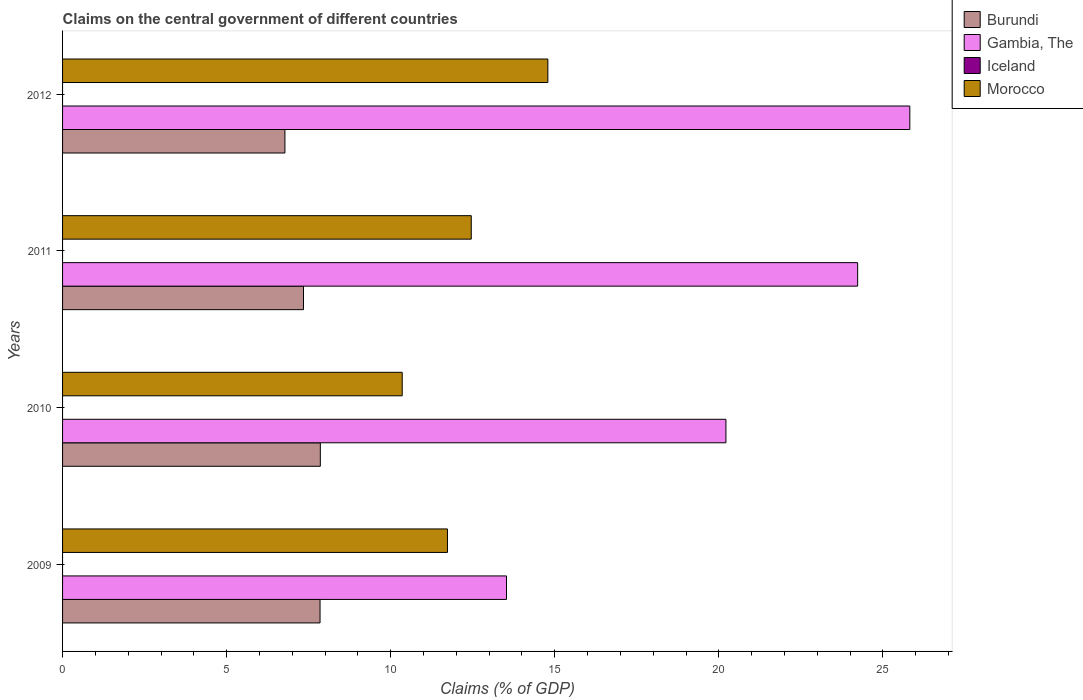How many groups of bars are there?
Provide a short and direct response. 4. Are the number of bars per tick equal to the number of legend labels?
Offer a terse response. No. Are the number of bars on each tick of the Y-axis equal?
Your response must be concise. Yes. How many bars are there on the 3rd tick from the bottom?
Your answer should be very brief. 3. What is the label of the 2nd group of bars from the top?
Offer a very short reply. 2011. In how many cases, is the number of bars for a given year not equal to the number of legend labels?
Make the answer very short. 4. What is the percentage of GDP claimed on the central government in Gambia, The in 2010?
Ensure brevity in your answer.  20.22. Across all years, what is the maximum percentage of GDP claimed on the central government in Morocco?
Your response must be concise. 14.79. Across all years, what is the minimum percentage of GDP claimed on the central government in Morocco?
Ensure brevity in your answer.  10.35. What is the total percentage of GDP claimed on the central government in Gambia, The in the graph?
Your answer should be compact. 83.8. What is the difference between the percentage of GDP claimed on the central government in Burundi in 2009 and that in 2011?
Your answer should be compact. 0.5. What is the difference between the percentage of GDP claimed on the central government in Iceland in 2010 and the percentage of GDP claimed on the central government in Morocco in 2011?
Make the answer very short. -12.46. What is the average percentage of GDP claimed on the central government in Gambia, The per year?
Provide a succinct answer. 20.95. In the year 2010, what is the difference between the percentage of GDP claimed on the central government in Burundi and percentage of GDP claimed on the central government in Gambia, The?
Provide a short and direct response. -12.36. What is the ratio of the percentage of GDP claimed on the central government in Burundi in 2009 to that in 2011?
Ensure brevity in your answer.  1.07. What is the difference between the highest and the second highest percentage of GDP claimed on the central government in Burundi?
Give a very brief answer. 0.01. What is the difference between the highest and the lowest percentage of GDP claimed on the central government in Gambia, The?
Provide a succinct answer. 12.29. In how many years, is the percentage of GDP claimed on the central government in Burundi greater than the average percentage of GDP claimed on the central government in Burundi taken over all years?
Your answer should be very brief. 2. Is the sum of the percentage of GDP claimed on the central government in Morocco in 2009 and 2012 greater than the maximum percentage of GDP claimed on the central government in Gambia, The across all years?
Your response must be concise. Yes. Is it the case that in every year, the sum of the percentage of GDP claimed on the central government in Burundi and percentage of GDP claimed on the central government in Iceland is greater than the sum of percentage of GDP claimed on the central government in Morocco and percentage of GDP claimed on the central government in Gambia, The?
Your response must be concise. No. How many bars are there?
Ensure brevity in your answer.  12. Does the graph contain any zero values?
Give a very brief answer. Yes. Where does the legend appear in the graph?
Your response must be concise. Top right. How many legend labels are there?
Give a very brief answer. 4. What is the title of the graph?
Your response must be concise. Claims on the central government of different countries. Does "Myanmar" appear as one of the legend labels in the graph?
Offer a very short reply. No. What is the label or title of the X-axis?
Your answer should be compact. Claims (% of GDP). What is the label or title of the Y-axis?
Offer a very short reply. Years. What is the Claims (% of GDP) of Burundi in 2009?
Give a very brief answer. 7.85. What is the Claims (% of GDP) in Gambia, The in 2009?
Offer a terse response. 13.53. What is the Claims (% of GDP) of Iceland in 2009?
Give a very brief answer. 0. What is the Claims (% of GDP) of Morocco in 2009?
Provide a succinct answer. 11.73. What is the Claims (% of GDP) of Burundi in 2010?
Give a very brief answer. 7.86. What is the Claims (% of GDP) in Gambia, The in 2010?
Offer a very short reply. 20.22. What is the Claims (% of GDP) of Morocco in 2010?
Keep it short and to the point. 10.35. What is the Claims (% of GDP) in Burundi in 2011?
Ensure brevity in your answer.  7.34. What is the Claims (% of GDP) in Gambia, The in 2011?
Provide a succinct answer. 24.23. What is the Claims (% of GDP) in Morocco in 2011?
Offer a very short reply. 12.46. What is the Claims (% of GDP) in Burundi in 2012?
Your response must be concise. 6.78. What is the Claims (% of GDP) in Gambia, The in 2012?
Offer a very short reply. 25.82. What is the Claims (% of GDP) of Morocco in 2012?
Ensure brevity in your answer.  14.79. Across all years, what is the maximum Claims (% of GDP) of Burundi?
Offer a very short reply. 7.86. Across all years, what is the maximum Claims (% of GDP) of Gambia, The?
Offer a terse response. 25.82. Across all years, what is the maximum Claims (% of GDP) of Morocco?
Ensure brevity in your answer.  14.79. Across all years, what is the minimum Claims (% of GDP) of Burundi?
Offer a terse response. 6.78. Across all years, what is the minimum Claims (% of GDP) of Gambia, The?
Your response must be concise. 13.53. Across all years, what is the minimum Claims (% of GDP) of Morocco?
Offer a terse response. 10.35. What is the total Claims (% of GDP) in Burundi in the graph?
Provide a succinct answer. 29.82. What is the total Claims (% of GDP) of Gambia, The in the graph?
Make the answer very short. 83.8. What is the total Claims (% of GDP) in Morocco in the graph?
Offer a very short reply. 49.33. What is the difference between the Claims (% of GDP) in Burundi in 2009 and that in 2010?
Your response must be concise. -0.01. What is the difference between the Claims (% of GDP) of Gambia, The in 2009 and that in 2010?
Your response must be concise. -6.69. What is the difference between the Claims (% of GDP) of Morocco in 2009 and that in 2010?
Offer a very short reply. 1.38. What is the difference between the Claims (% of GDP) of Burundi in 2009 and that in 2011?
Your answer should be very brief. 0.5. What is the difference between the Claims (% of GDP) of Gambia, The in 2009 and that in 2011?
Offer a terse response. -10.7. What is the difference between the Claims (% of GDP) of Morocco in 2009 and that in 2011?
Offer a terse response. -0.73. What is the difference between the Claims (% of GDP) of Burundi in 2009 and that in 2012?
Offer a very short reply. 1.07. What is the difference between the Claims (% of GDP) of Gambia, The in 2009 and that in 2012?
Keep it short and to the point. -12.29. What is the difference between the Claims (% of GDP) of Morocco in 2009 and that in 2012?
Provide a short and direct response. -3.06. What is the difference between the Claims (% of GDP) in Burundi in 2010 and that in 2011?
Your answer should be compact. 0.51. What is the difference between the Claims (% of GDP) in Gambia, The in 2010 and that in 2011?
Give a very brief answer. -4.01. What is the difference between the Claims (% of GDP) of Morocco in 2010 and that in 2011?
Provide a short and direct response. -2.1. What is the difference between the Claims (% of GDP) of Burundi in 2010 and that in 2012?
Offer a very short reply. 1.08. What is the difference between the Claims (% of GDP) of Gambia, The in 2010 and that in 2012?
Your answer should be very brief. -5.6. What is the difference between the Claims (% of GDP) in Morocco in 2010 and that in 2012?
Your answer should be compact. -4.44. What is the difference between the Claims (% of GDP) in Burundi in 2011 and that in 2012?
Your response must be concise. 0.57. What is the difference between the Claims (% of GDP) in Gambia, The in 2011 and that in 2012?
Keep it short and to the point. -1.59. What is the difference between the Claims (% of GDP) in Morocco in 2011 and that in 2012?
Your answer should be compact. -2.33. What is the difference between the Claims (% of GDP) in Burundi in 2009 and the Claims (% of GDP) in Gambia, The in 2010?
Offer a very short reply. -12.37. What is the difference between the Claims (% of GDP) of Burundi in 2009 and the Claims (% of GDP) of Morocco in 2010?
Your answer should be very brief. -2.5. What is the difference between the Claims (% of GDP) of Gambia, The in 2009 and the Claims (% of GDP) of Morocco in 2010?
Give a very brief answer. 3.18. What is the difference between the Claims (% of GDP) in Burundi in 2009 and the Claims (% of GDP) in Gambia, The in 2011?
Offer a very short reply. -16.38. What is the difference between the Claims (% of GDP) in Burundi in 2009 and the Claims (% of GDP) in Morocco in 2011?
Keep it short and to the point. -4.61. What is the difference between the Claims (% of GDP) in Gambia, The in 2009 and the Claims (% of GDP) in Morocco in 2011?
Offer a very short reply. 1.07. What is the difference between the Claims (% of GDP) of Burundi in 2009 and the Claims (% of GDP) of Gambia, The in 2012?
Make the answer very short. -17.97. What is the difference between the Claims (% of GDP) of Burundi in 2009 and the Claims (% of GDP) of Morocco in 2012?
Provide a succinct answer. -6.94. What is the difference between the Claims (% of GDP) of Gambia, The in 2009 and the Claims (% of GDP) of Morocco in 2012?
Provide a succinct answer. -1.26. What is the difference between the Claims (% of GDP) of Burundi in 2010 and the Claims (% of GDP) of Gambia, The in 2011?
Your answer should be compact. -16.38. What is the difference between the Claims (% of GDP) of Burundi in 2010 and the Claims (% of GDP) of Morocco in 2011?
Provide a short and direct response. -4.6. What is the difference between the Claims (% of GDP) in Gambia, The in 2010 and the Claims (% of GDP) in Morocco in 2011?
Keep it short and to the point. 7.76. What is the difference between the Claims (% of GDP) of Burundi in 2010 and the Claims (% of GDP) of Gambia, The in 2012?
Keep it short and to the point. -17.97. What is the difference between the Claims (% of GDP) of Burundi in 2010 and the Claims (% of GDP) of Morocco in 2012?
Make the answer very short. -6.93. What is the difference between the Claims (% of GDP) of Gambia, The in 2010 and the Claims (% of GDP) of Morocco in 2012?
Offer a terse response. 5.43. What is the difference between the Claims (% of GDP) of Burundi in 2011 and the Claims (% of GDP) of Gambia, The in 2012?
Your answer should be very brief. -18.48. What is the difference between the Claims (% of GDP) in Burundi in 2011 and the Claims (% of GDP) in Morocco in 2012?
Your response must be concise. -7.45. What is the difference between the Claims (% of GDP) of Gambia, The in 2011 and the Claims (% of GDP) of Morocco in 2012?
Give a very brief answer. 9.44. What is the average Claims (% of GDP) in Burundi per year?
Offer a very short reply. 7.46. What is the average Claims (% of GDP) in Gambia, The per year?
Offer a very short reply. 20.95. What is the average Claims (% of GDP) in Iceland per year?
Offer a very short reply. 0. What is the average Claims (% of GDP) of Morocco per year?
Offer a terse response. 12.33. In the year 2009, what is the difference between the Claims (% of GDP) of Burundi and Claims (% of GDP) of Gambia, The?
Make the answer very short. -5.68. In the year 2009, what is the difference between the Claims (% of GDP) of Burundi and Claims (% of GDP) of Morocco?
Your response must be concise. -3.88. In the year 2009, what is the difference between the Claims (% of GDP) of Gambia, The and Claims (% of GDP) of Morocco?
Provide a succinct answer. 1.8. In the year 2010, what is the difference between the Claims (% of GDP) in Burundi and Claims (% of GDP) in Gambia, The?
Make the answer very short. -12.36. In the year 2010, what is the difference between the Claims (% of GDP) of Burundi and Claims (% of GDP) of Morocco?
Ensure brevity in your answer.  -2.5. In the year 2010, what is the difference between the Claims (% of GDP) in Gambia, The and Claims (% of GDP) in Morocco?
Keep it short and to the point. 9.87. In the year 2011, what is the difference between the Claims (% of GDP) of Burundi and Claims (% of GDP) of Gambia, The?
Your answer should be very brief. -16.89. In the year 2011, what is the difference between the Claims (% of GDP) of Burundi and Claims (% of GDP) of Morocco?
Your answer should be very brief. -5.11. In the year 2011, what is the difference between the Claims (% of GDP) of Gambia, The and Claims (% of GDP) of Morocco?
Provide a short and direct response. 11.78. In the year 2012, what is the difference between the Claims (% of GDP) in Burundi and Claims (% of GDP) in Gambia, The?
Make the answer very short. -19.04. In the year 2012, what is the difference between the Claims (% of GDP) of Burundi and Claims (% of GDP) of Morocco?
Provide a succinct answer. -8.01. In the year 2012, what is the difference between the Claims (% of GDP) in Gambia, The and Claims (% of GDP) in Morocco?
Keep it short and to the point. 11.03. What is the ratio of the Claims (% of GDP) in Burundi in 2009 to that in 2010?
Your response must be concise. 1. What is the ratio of the Claims (% of GDP) in Gambia, The in 2009 to that in 2010?
Make the answer very short. 0.67. What is the ratio of the Claims (% of GDP) of Morocco in 2009 to that in 2010?
Provide a succinct answer. 1.13. What is the ratio of the Claims (% of GDP) in Burundi in 2009 to that in 2011?
Your answer should be compact. 1.07. What is the ratio of the Claims (% of GDP) in Gambia, The in 2009 to that in 2011?
Provide a short and direct response. 0.56. What is the ratio of the Claims (% of GDP) in Morocco in 2009 to that in 2011?
Keep it short and to the point. 0.94. What is the ratio of the Claims (% of GDP) in Burundi in 2009 to that in 2012?
Give a very brief answer. 1.16. What is the ratio of the Claims (% of GDP) in Gambia, The in 2009 to that in 2012?
Provide a short and direct response. 0.52. What is the ratio of the Claims (% of GDP) of Morocco in 2009 to that in 2012?
Offer a terse response. 0.79. What is the ratio of the Claims (% of GDP) of Burundi in 2010 to that in 2011?
Provide a short and direct response. 1.07. What is the ratio of the Claims (% of GDP) of Gambia, The in 2010 to that in 2011?
Make the answer very short. 0.83. What is the ratio of the Claims (% of GDP) of Morocco in 2010 to that in 2011?
Your response must be concise. 0.83. What is the ratio of the Claims (% of GDP) of Burundi in 2010 to that in 2012?
Provide a succinct answer. 1.16. What is the ratio of the Claims (% of GDP) of Gambia, The in 2010 to that in 2012?
Offer a very short reply. 0.78. What is the ratio of the Claims (% of GDP) in Morocco in 2010 to that in 2012?
Offer a very short reply. 0.7. What is the ratio of the Claims (% of GDP) in Burundi in 2011 to that in 2012?
Provide a succinct answer. 1.08. What is the ratio of the Claims (% of GDP) of Gambia, The in 2011 to that in 2012?
Ensure brevity in your answer.  0.94. What is the ratio of the Claims (% of GDP) in Morocco in 2011 to that in 2012?
Offer a very short reply. 0.84. What is the difference between the highest and the second highest Claims (% of GDP) in Burundi?
Keep it short and to the point. 0.01. What is the difference between the highest and the second highest Claims (% of GDP) in Gambia, The?
Keep it short and to the point. 1.59. What is the difference between the highest and the second highest Claims (% of GDP) of Morocco?
Offer a very short reply. 2.33. What is the difference between the highest and the lowest Claims (% of GDP) of Burundi?
Give a very brief answer. 1.08. What is the difference between the highest and the lowest Claims (% of GDP) in Gambia, The?
Give a very brief answer. 12.29. What is the difference between the highest and the lowest Claims (% of GDP) in Morocco?
Your answer should be compact. 4.44. 